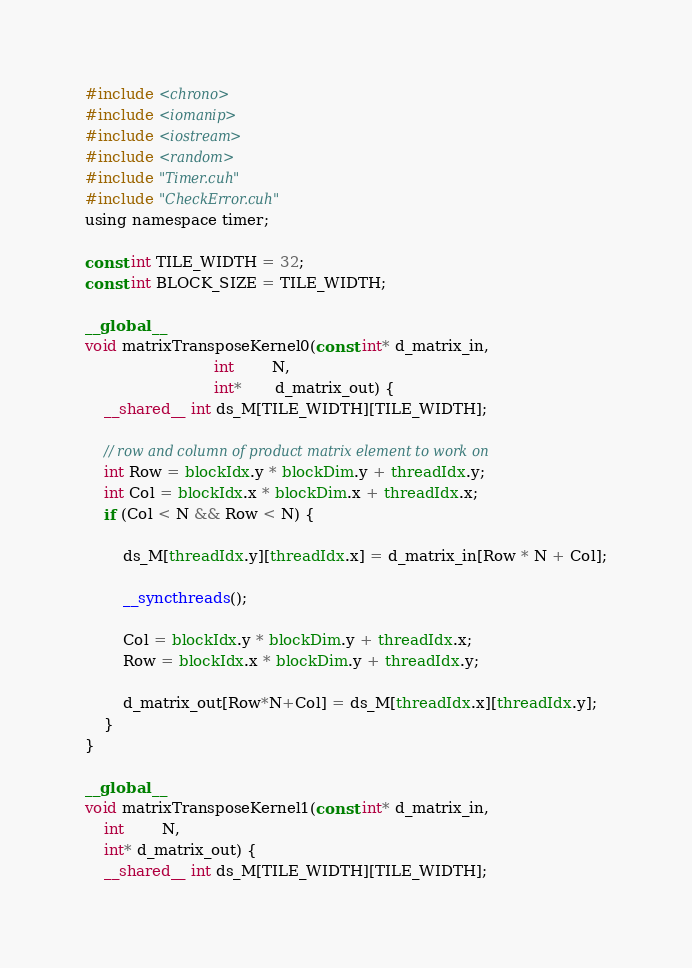Convert code to text. <code><loc_0><loc_0><loc_500><loc_500><_Cuda_>#include <chrono>
#include <iomanip>
#include <iostream>
#include <random>
#include "Timer.cuh"
#include "CheckError.cuh"
using namespace timer;

const int TILE_WIDTH = 32;
const int BLOCK_SIZE = TILE_WIDTH;

__global__
void matrixTransposeKernel0(const int* d_matrix_in,
                           int        N,
                           int*       d_matrix_out) {
	__shared__ int ds_M[TILE_WIDTH][TILE_WIDTH];

	// row and column of product matrix element to work on
	int Row = blockIdx.y * blockDim.y + threadIdx.y;
	int Col = blockIdx.x * blockDim.x + threadIdx.x;
	if (Col < N && Row < N) {

		ds_M[threadIdx.y][threadIdx.x] = d_matrix_in[Row * N + Col];

		__syncthreads();

		Col = blockIdx.y * blockDim.y + threadIdx.x;
		Row = blockIdx.x * blockDim.y + threadIdx.y;

		d_matrix_out[Row*N+Col] = ds_M[threadIdx.x][threadIdx.y]; 
	}
}

__global__
void matrixTransposeKernel1(const int* d_matrix_in,
    int        N,
    int* d_matrix_out) {
    __shared__ int ds_M[TILE_WIDTH][TILE_WIDTH];
</code> 